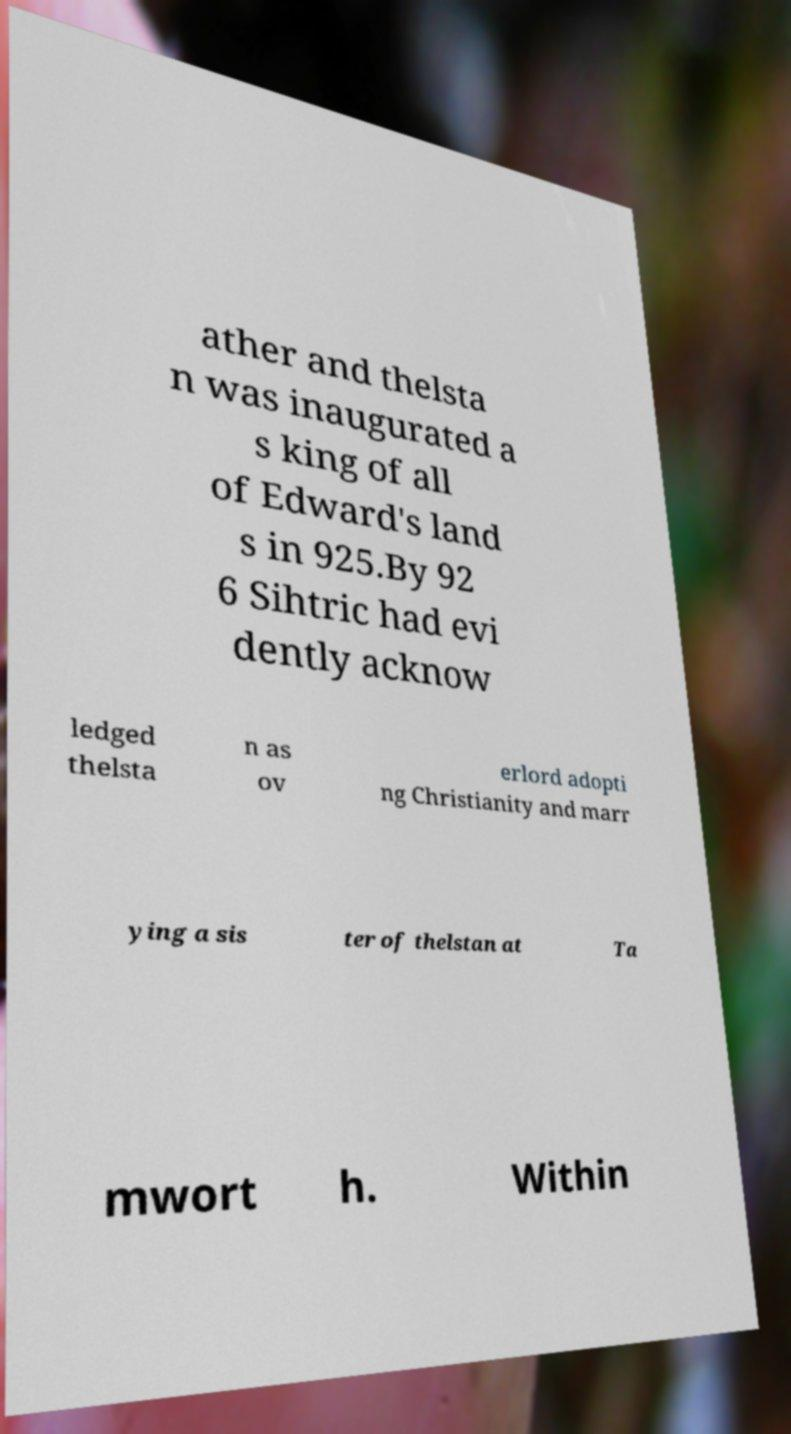Can you read and provide the text displayed in the image?This photo seems to have some interesting text. Can you extract and type it out for me? ather and thelsta n was inaugurated a s king of all of Edward's land s in 925.By 92 6 Sihtric had evi dently acknow ledged thelsta n as ov erlord adopti ng Christianity and marr ying a sis ter of thelstan at Ta mwort h. Within 